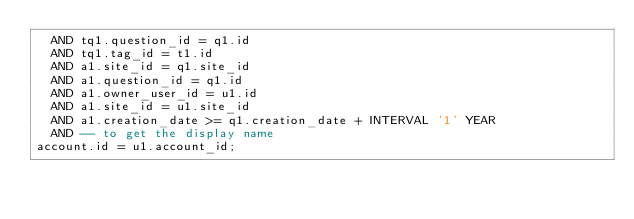<code> <loc_0><loc_0><loc_500><loc_500><_SQL_>  AND tq1.question_id = q1.id
  AND tq1.tag_id = t1.id
  AND a1.site_id = q1.site_id
  AND a1.question_id = q1.id
  AND a1.owner_user_id = u1.id
  AND a1.site_id = u1.site_id
  AND a1.creation_date >= q1.creation_date + INTERVAL '1' YEAR
  AND -- to get the display name
account.id = u1.account_id;</code> 